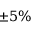<formula> <loc_0><loc_0><loc_500><loc_500>\pm 5 \%</formula> 